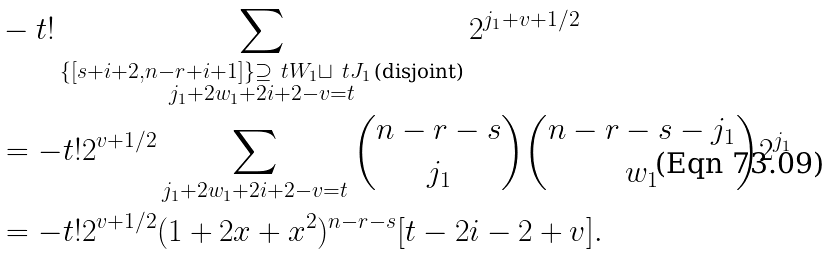<formula> <loc_0><loc_0><loc_500><loc_500>& - t ! \sum _ { \substack { \{ [ s + i + 2 , n - r + i + 1 ] \} \supseteq \ t W _ { 1 } \sqcup \ t J _ { 1 } \, \text {(disjoint)} \\ j _ { 1 } + 2 w _ { 1 } + 2 i + 2 - v = t } } 2 ^ { j _ { 1 } + v + 1 / 2 } \\ & = - t ! 2 ^ { v + 1 / 2 } \sum _ { j _ { 1 } + 2 w _ { 1 } + 2 i + 2 - v = t } \binom { n - r - s } { j _ { 1 } } \binom { n - r - s - j _ { 1 } } { w _ { 1 } } 2 ^ { j _ { 1 } } \\ & = - t ! 2 ^ { v + 1 / 2 } ( 1 + 2 x + x ^ { 2 } ) ^ { n - r - s } [ t - 2 i - 2 + v ] . \\</formula> 